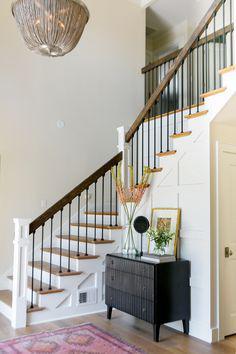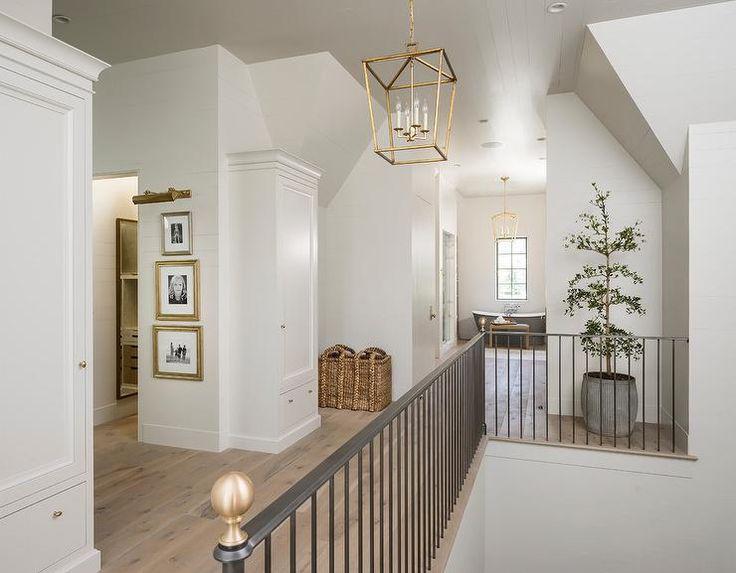The first image is the image on the left, the second image is the image on the right. Assess this claim about the two images: "The right image is taken from downstairs.". Correct or not? Answer yes or no. No. The first image is the image on the left, the second image is the image on the right. Analyze the images presented: Is the assertion "The left image has visible stair steps, the right image does not." valid? Answer yes or no. Yes. 